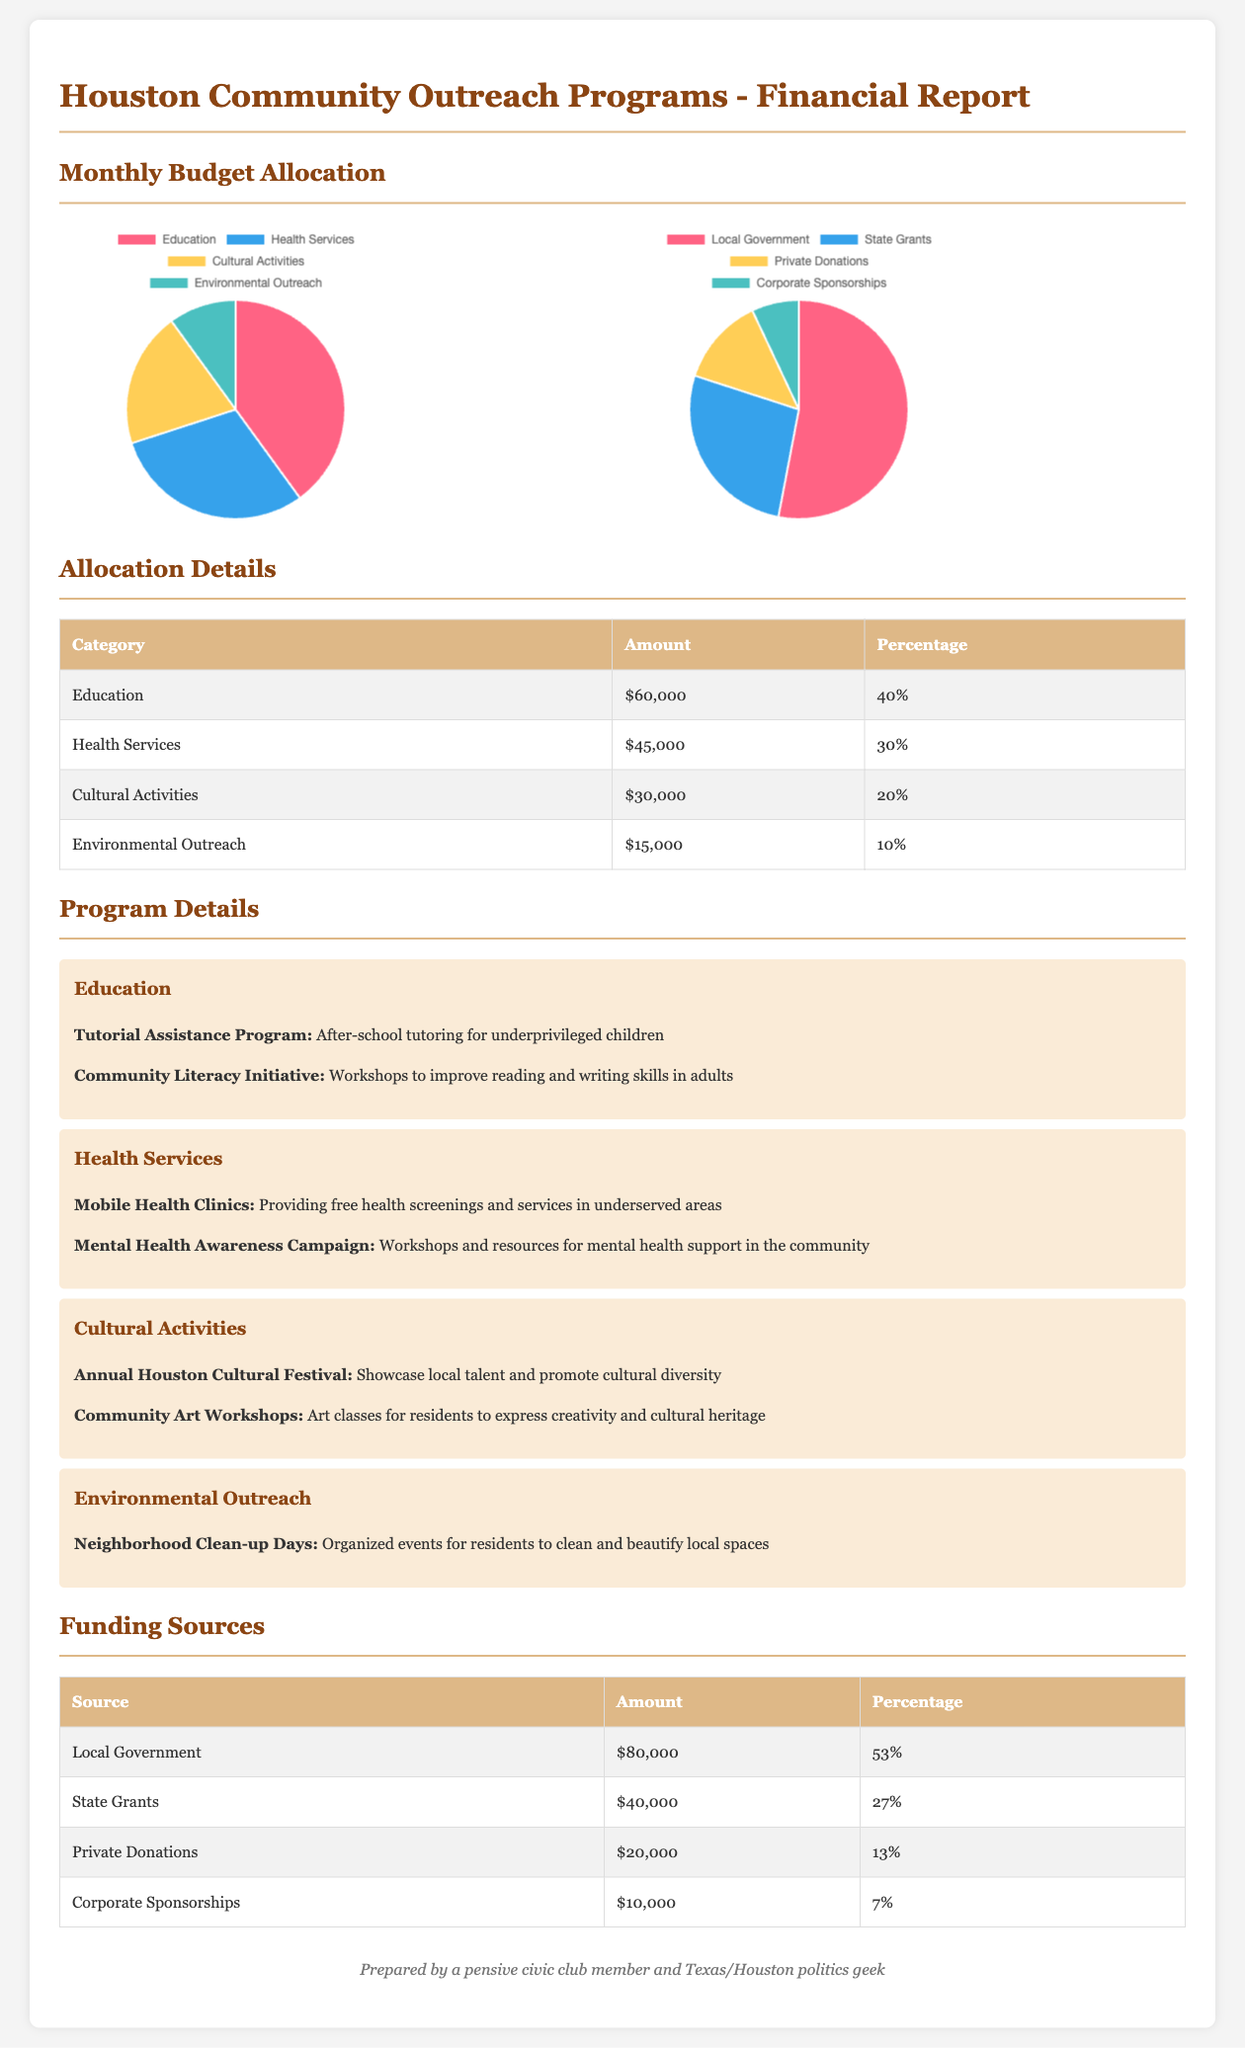What is the total budget allocation for Education? The total budget allocation for Education is stated in the allocation details section of the document as $60,000.
Answer: $60,000 What percentage of the budget is allocated to Health Services? The percentage allocated to Health Services is clearly outlined in the table, which shows it to be 30%.
Answer: 30% What is the funding amount from Local Government? The amount from Local Government is shown in the funding sources table, which indicates it as $80,000.
Answer: $80,000 Which category has the lowest budget allocation? The category with the lowest allocation can be found in the allocation details, and it is Environmental Outreach with $15,000.
Answer: Environmental Outreach What is the total funding from Corporate Sponsorships? The total funding from Corporate Sponsorships is found in the funding sources table, which lists it as $10,000.
Answer: $10,000 How much percentage of the total budget comes from Private Donations? The percentage of the total budget coming from Private Donations is specified as 13% in the funding sources table.
Answer: 13% What are the two main programs listed under Health Services? The two main programs under Health Services are mentioned in the program details section: Mobile Health Clinics and Mental Health Awareness Campaign.
Answer: Mobile Health Clinics, Mental Health Awareness Campaign What is the total budget allocation for Cultural Activities? The total budget allocation for Cultural Activities is detailed in the allocation section, which states it as $30,000.
Answer: $30,000 What is the percentage allocated to Environmental Outreach? The percentage for Environmental Outreach is found in the allocation details table, and it is 10%.
Answer: 10% 